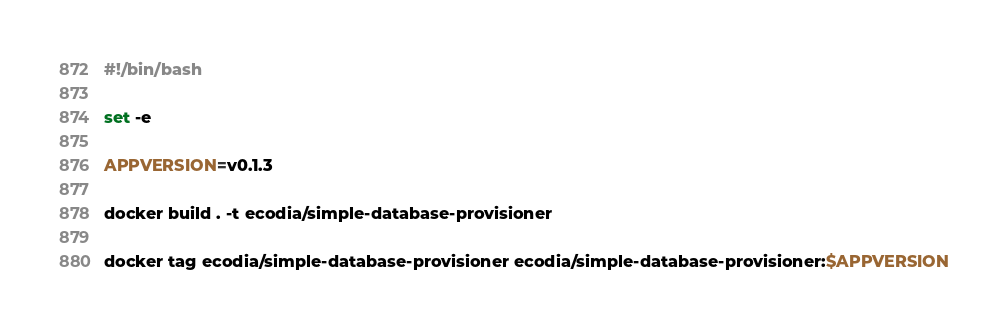Convert code to text. <code><loc_0><loc_0><loc_500><loc_500><_Bash_>#!/bin/bash

set -e

APPVERSION=v0.1.3

docker build . -t ecodia/simple-database-provisioner

docker tag ecodia/simple-database-provisioner ecodia/simple-database-provisioner:$APPVERSION
</code> 